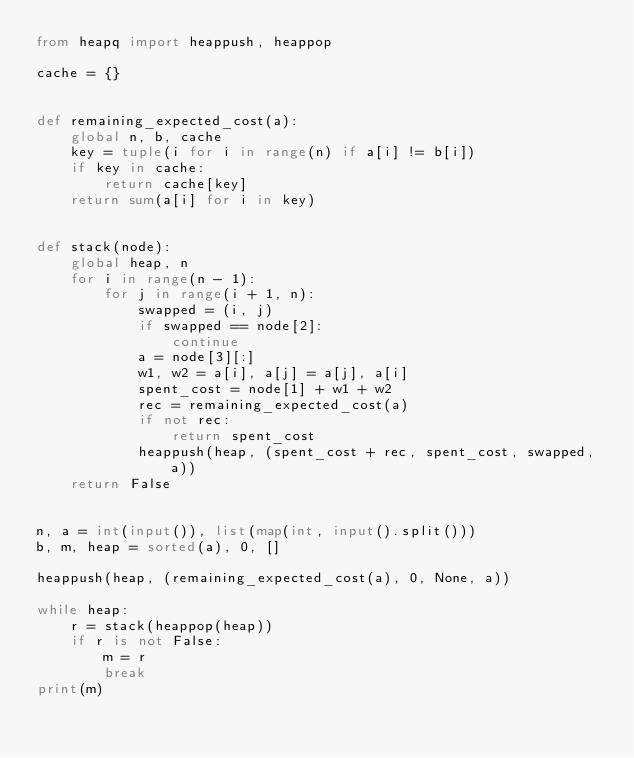<code> <loc_0><loc_0><loc_500><loc_500><_Python_>from heapq import heappush, heappop

cache = {}


def remaining_expected_cost(a):
    global n, b, cache
    key = tuple(i for i in range(n) if a[i] != b[i])
    if key in cache:
        return cache[key]
    return sum(a[i] for i in key)


def stack(node):
    global heap, n
    for i in range(n - 1):
        for j in range(i + 1, n):
            swapped = (i, j)
            if swapped == node[2]:
                continue
            a = node[3][:]
            w1, w2 = a[i], a[j] = a[j], a[i]
            spent_cost = node[1] + w1 + w2
            rec = remaining_expected_cost(a)
            if not rec:
                return spent_cost
            heappush(heap, (spent_cost + rec, spent_cost, swapped, a))
    return False


n, a = int(input()), list(map(int, input().split()))
b, m, heap = sorted(a), 0, []

heappush(heap, (remaining_expected_cost(a), 0, None, a))

while heap:
    r = stack(heappop(heap))
    if r is not False:
        m = r
        break
print(m)</code> 